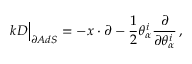Convert formula to latex. <formula><loc_0><loc_0><loc_500><loc_500>k D \Big | _ { \partial A d S } = - x \cdot \partial - \frac { 1 } { 2 } \theta _ { \alpha } ^ { i } \frac { \partial } { \partial \theta _ { \alpha } ^ { i } } \, ,</formula> 